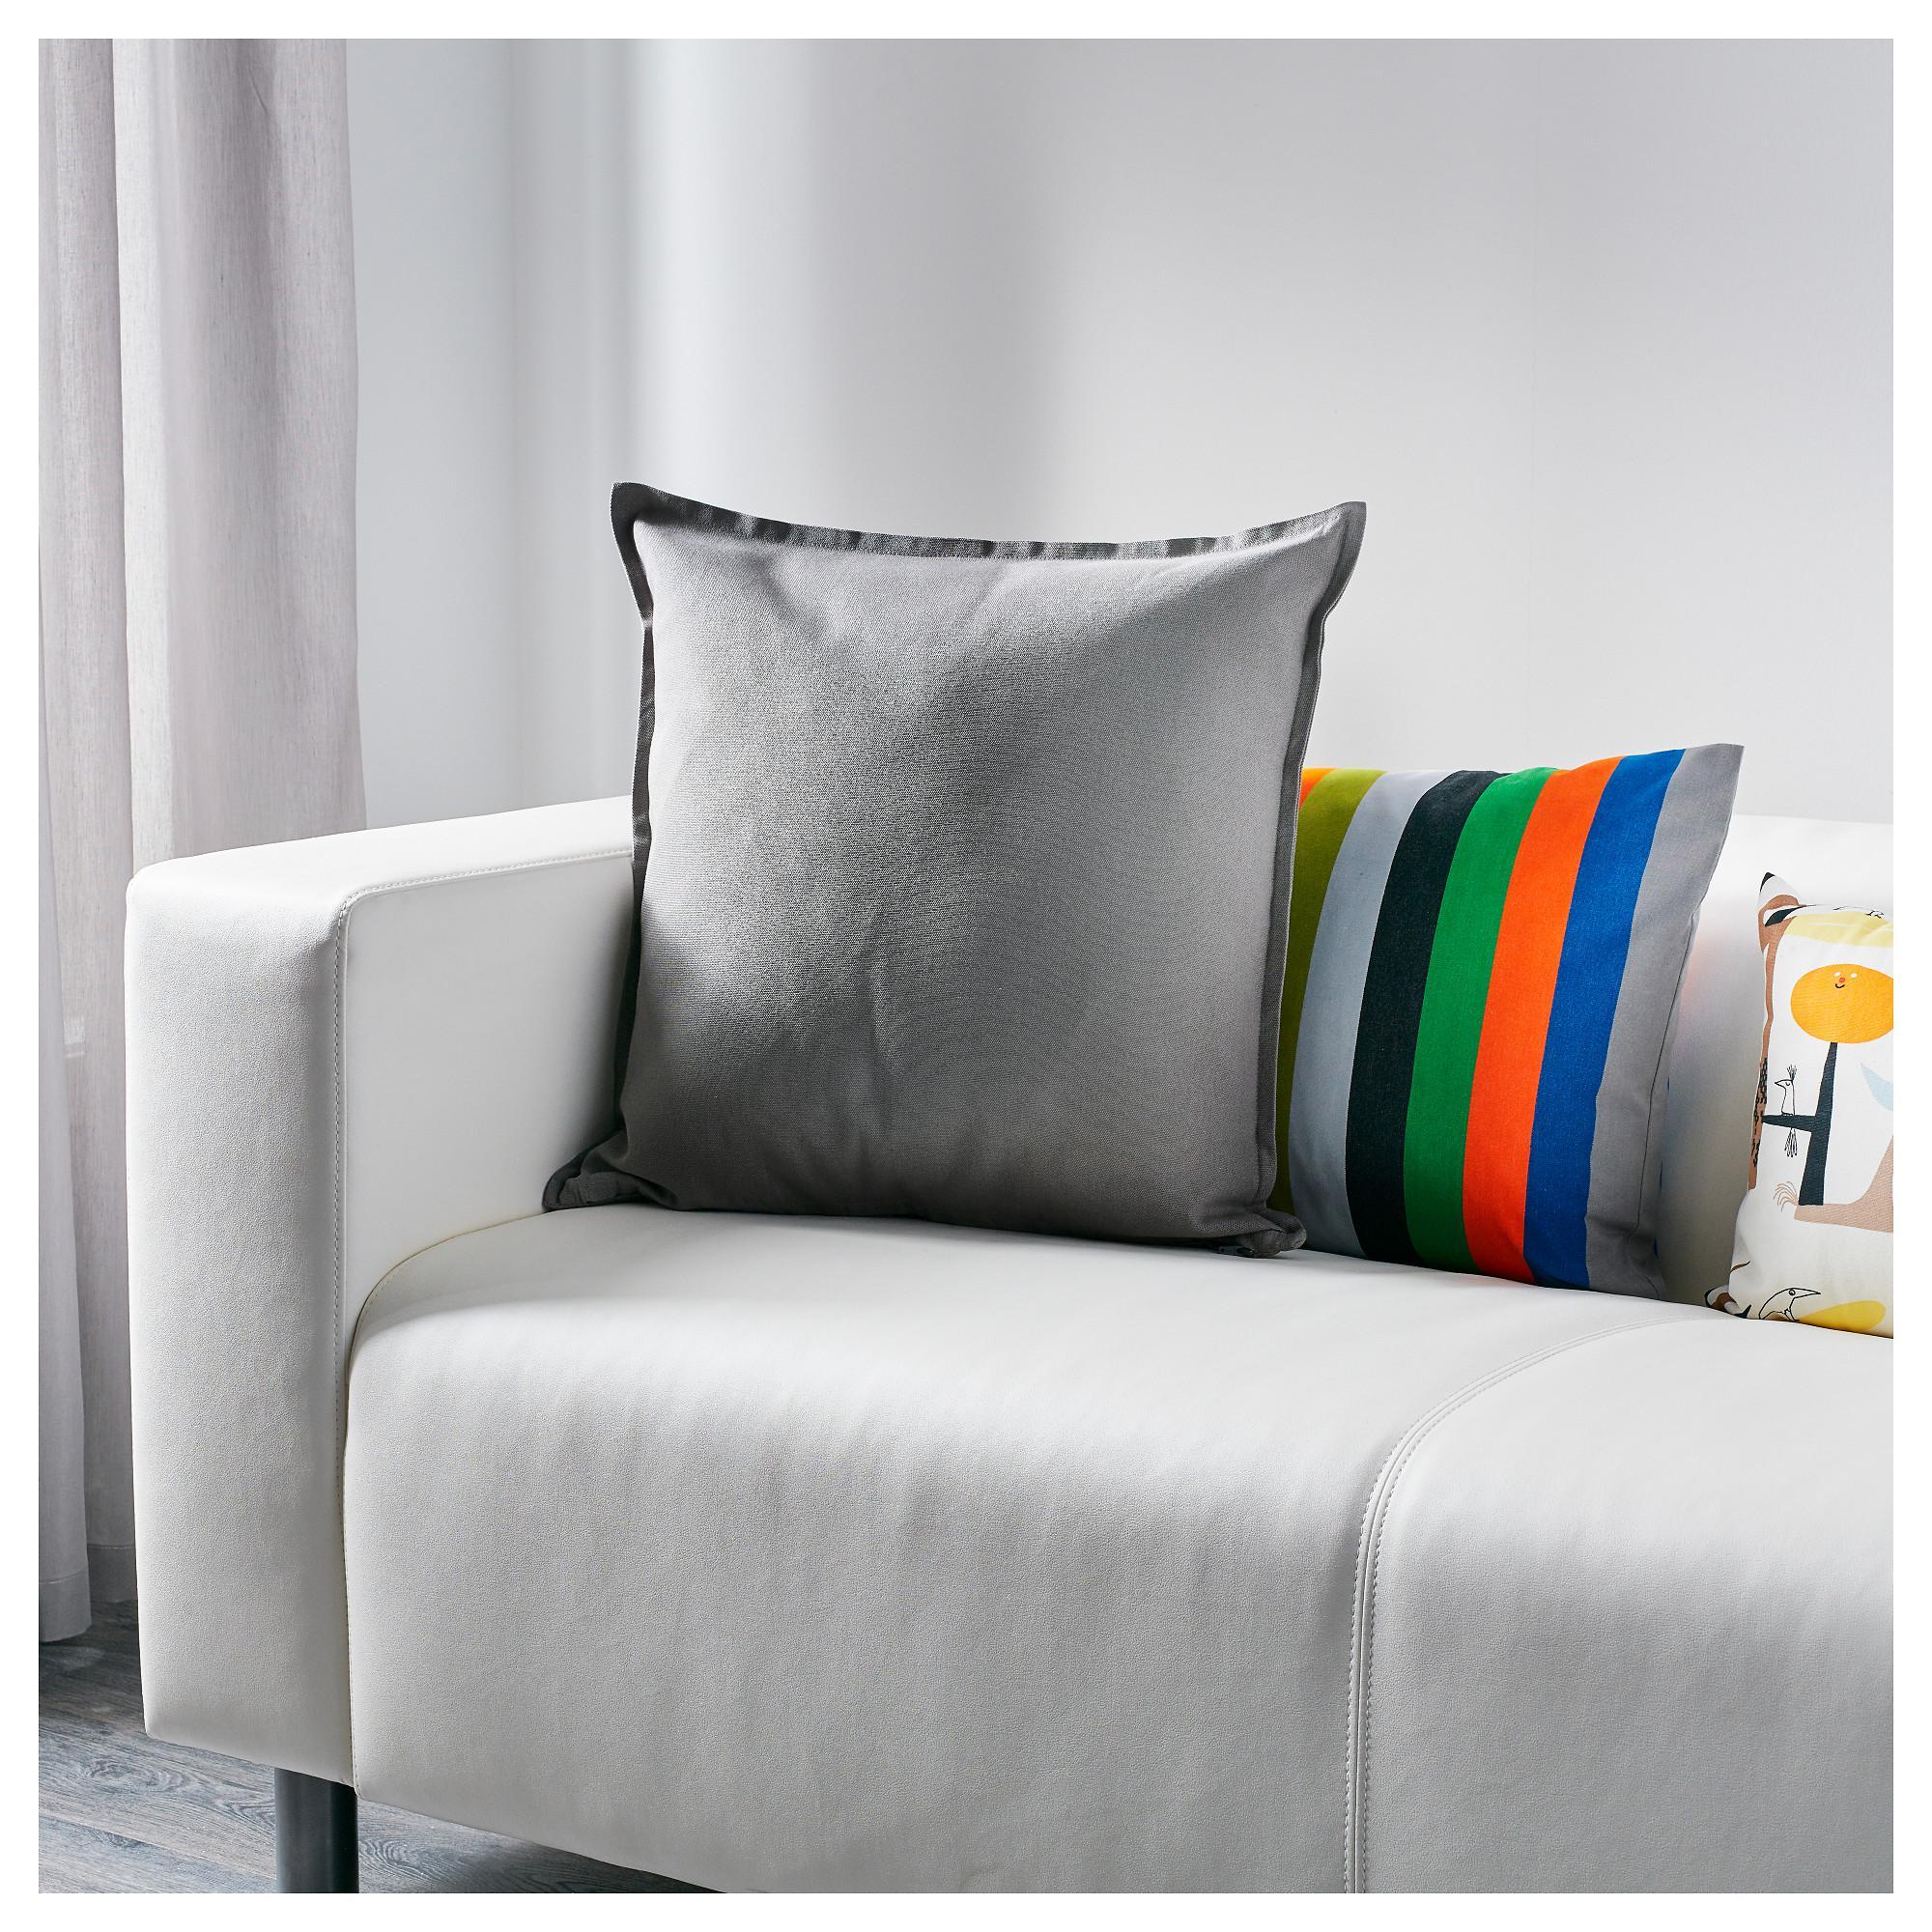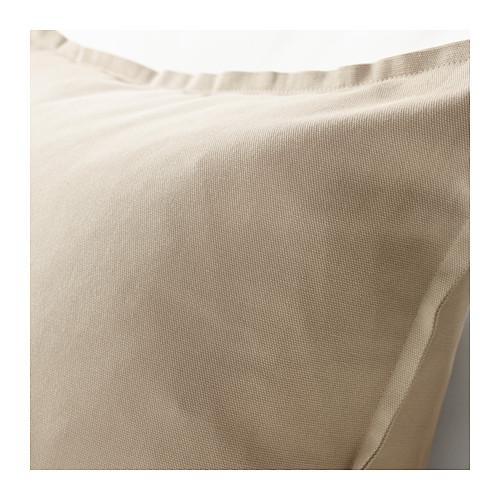The first image is the image on the left, the second image is the image on the right. Given the left and right images, does the statement "One image shows pillows on a sofa and the other shows a single pillow." hold true? Answer yes or no. Yes. The first image is the image on the left, the second image is the image on the right. Evaluate the accuracy of this statement regarding the images: "An image shows the corner of a white sofa containing a solid-colored pillow overlapping a striped pillow, and a smaller printed pillow to the right.". Is it true? Answer yes or no. Yes. 